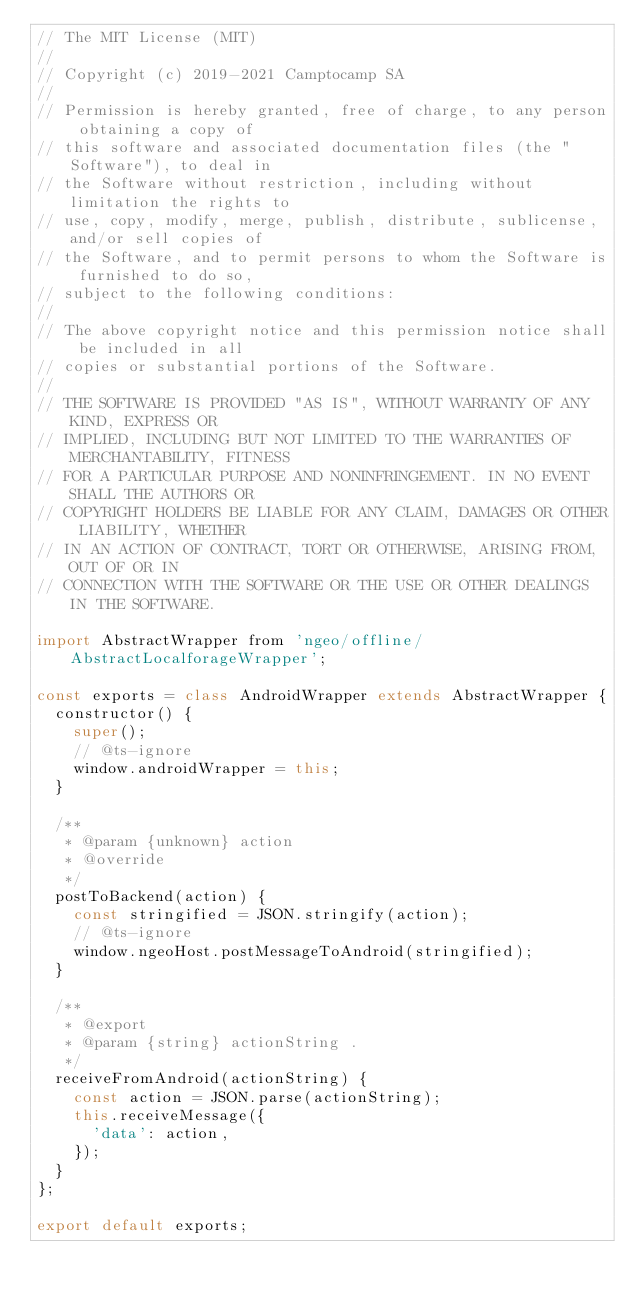<code> <loc_0><loc_0><loc_500><loc_500><_JavaScript_>// The MIT License (MIT)
//
// Copyright (c) 2019-2021 Camptocamp SA
//
// Permission is hereby granted, free of charge, to any person obtaining a copy of
// this software and associated documentation files (the "Software"), to deal in
// the Software without restriction, including without limitation the rights to
// use, copy, modify, merge, publish, distribute, sublicense, and/or sell copies of
// the Software, and to permit persons to whom the Software is furnished to do so,
// subject to the following conditions:
//
// The above copyright notice and this permission notice shall be included in all
// copies or substantial portions of the Software.
//
// THE SOFTWARE IS PROVIDED "AS IS", WITHOUT WARRANTY OF ANY KIND, EXPRESS OR
// IMPLIED, INCLUDING BUT NOT LIMITED TO THE WARRANTIES OF MERCHANTABILITY, FITNESS
// FOR A PARTICULAR PURPOSE AND NONINFRINGEMENT. IN NO EVENT SHALL THE AUTHORS OR
// COPYRIGHT HOLDERS BE LIABLE FOR ANY CLAIM, DAMAGES OR OTHER LIABILITY, WHETHER
// IN AN ACTION OF CONTRACT, TORT OR OTHERWISE, ARISING FROM, OUT OF OR IN
// CONNECTION WITH THE SOFTWARE OR THE USE OR OTHER DEALINGS IN THE SOFTWARE.

import AbstractWrapper from 'ngeo/offline/AbstractLocalforageWrapper';

const exports = class AndroidWrapper extends AbstractWrapper {
  constructor() {
    super();
    // @ts-ignore
    window.androidWrapper = this;
  }

  /**
   * @param {unknown} action
   * @override
   */
  postToBackend(action) {
    const stringified = JSON.stringify(action);
    // @ts-ignore
    window.ngeoHost.postMessageToAndroid(stringified);
  }

  /**
   * @export
   * @param {string} actionString .
   */
  receiveFromAndroid(actionString) {
    const action = JSON.parse(actionString);
    this.receiveMessage({
      'data': action,
    });
  }
};

export default exports;
</code> 